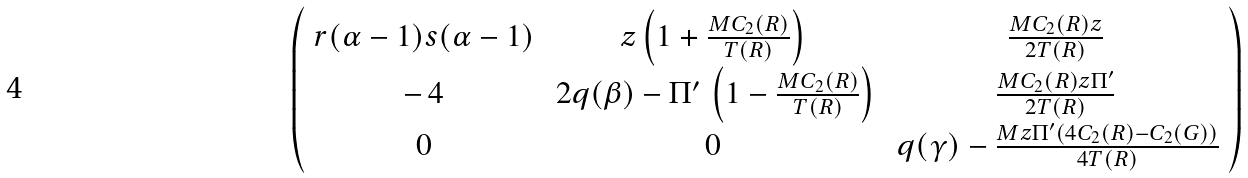<formula> <loc_0><loc_0><loc_500><loc_500>\left ( \begin{array} { c c c } r ( \alpha - 1 ) s ( \alpha - 1 ) & z \left ( 1 + \frac { M C _ { 2 } ( R ) } { T ( R ) } \right ) & \frac { M C _ { 2 } ( R ) z } { 2 T ( R ) } \\ - \, 4 & \, 2 q ( \beta ) - \Pi ^ { \prime } \, \left ( 1 - \frac { M C _ { 2 } ( R ) } { T ( R ) } \right ) & \frac { M C _ { 2 } ( R ) z \Pi ^ { \prime } } { 2 T ( R ) } \\ 0 & 0 & \, q ( \gamma ) - \frac { M z \Pi ^ { \prime } ( 4 C _ { 2 } ( R ) - C _ { 2 } ( G ) ) } { 4 T ( R ) } \\ \end{array} \right )</formula> 